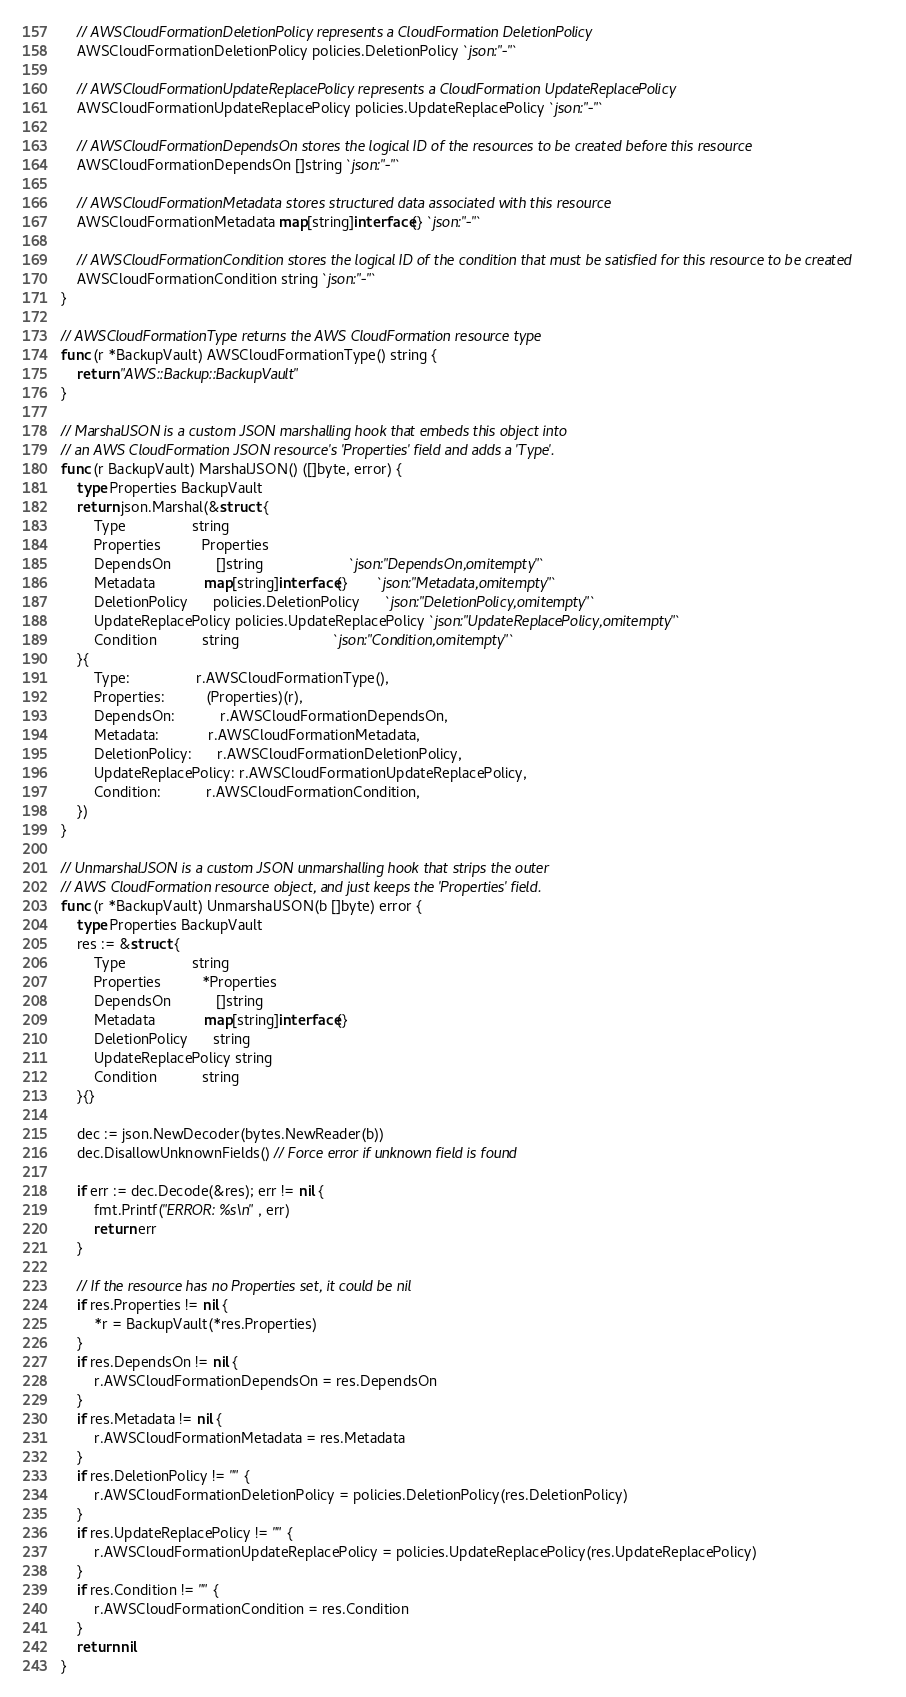Convert code to text. <code><loc_0><loc_0><loc_500><loc_500><_Go_>
	// AWSCloudFormationDeletionPolicy represents a CloudFormation DeletionPolicy
	AWSCloudFormationDeletionPolicy policies.DeletionPolicy `json:"-"`

	// AWSCloudFormationUpdateReplacePolicy represents a CloudFormation UpdateReplacePolicy
	AWSCloudFormationUpdateReplacePolicy policies.UpdateReplacePolicy `json:"-"`

	// AWSCloudFormationDependsOn stores the logical ID of the resources to be created before this resource
	AWSCloudFormationDependsOn []string `json:"-"`

	// AWSCloudFormationMetadata stores structured data associated with this resource
	AWSCloudFormationMetadata map[string]interface{} `json:"-"`

	// AWSCloudFormationCondition stores the logical ID of the condition that must be satisfied for this resource to be created
	AWSCloudFormationCondition string `json:"-"`
}

// AWSCloudFormationType returns the AWS CloudFormation resource type
func (r *BackupVault) AWSCloudFormationType() string {
	return "AWS::Backup::BackupVault"
}

// MarshalJSON is a custom JSON marshalling hook that embeds this object into
// an AWS CloudFormation JSON resource's 'Properties' field and adds a 'Type'.
func (r BackupVault) MarshalJSON() ([]byte, error) {
	type Properties BackupVault
	return json.Marshal(&struct {
		Type                string
		Properties          Properties
		DependsOn           []string                     `json:"DependsOn,omitempty"`
		Metadata            map[string]interface{}       `json:"Metadata,omitempty"`
		DeletionPolicy      policies.DeletionPolicy      `json:"DeletionPolicy,omitempty"`
		UpdateReplacePolicy policies.UpdateReplacePolicy `json:"UpdateReplacePolicy,omitempty"`
		Condition           string                       `json:"Condition,omitempty"`
	}{
		Type:                r.AWSCloudFormationType(),
		Properties:          (Properties)(r),
		DependsOn:           r.AWSCloudFormationDependsOn,
		Metadata:            r.AWSCloudFormationMetadata,
		DeletionPolicy:      r.AWSCloudFormationDeletionPolicy,
		UpdateReplacePolicy: r.AWSCloudFormationUpdateReplacePolicy,
		Condition:           r.AWSCloudFormationCondition,
	})
}

// UnmarshalJSON is a custom JSON unmarshalling hook that strips the outer
// AWS CloudFormation resource object, and just keeps the 'Properties' field.
func (r *BackupVault) UnmarshalJSON(b []byte) error {
	type Properties BackupVault
	res := &struct {
		Type                string
		Properties          *Properties
		DependsOn           []string
		Metadata            map[string]interface{}
		DeletionPolicy      string
		UpdateReplacePolicy string
		Condition           string
	}{}

	dec := json.NewDecoder(bytes.NewReader(b))
	dec.DisallowUnknownFields() // Force error if unknown field is found

	if err := dec.Decode(&res); err != nil {
		fmt.Printf("ERROR: %s\n", err)
		return err
	}

	// If the resource has no Properties set, it could be nil
	if res.Properties != nil {
		*r = BackupVault(*res.Properties)
	}
	if res.DependsOn != nil {
		r.AWSCloudFormationDependsOn = res.DependsOn
	}
	if res.Metadata != nil {
		r.AWSCloudFormationMetadata = res.Metadata
	}
	if res.DeletionPolicy != "" {
		r.AWSCloudFormationDeletionPolicy = policies.DeletionPolicy(res.DeletionPolicy)
	}
	if res.UpdateReplacePolicy != "" {
		r.AWSCloudFormationUpdateReplacePolicy = policies.UpdateReplacePolicy(res.UpdateReplacePolicy)
	}
	if res.Condition != "" {
		r.AWSCloudFormationCondition = res.Condition
	}
	return nil
}
</code> 